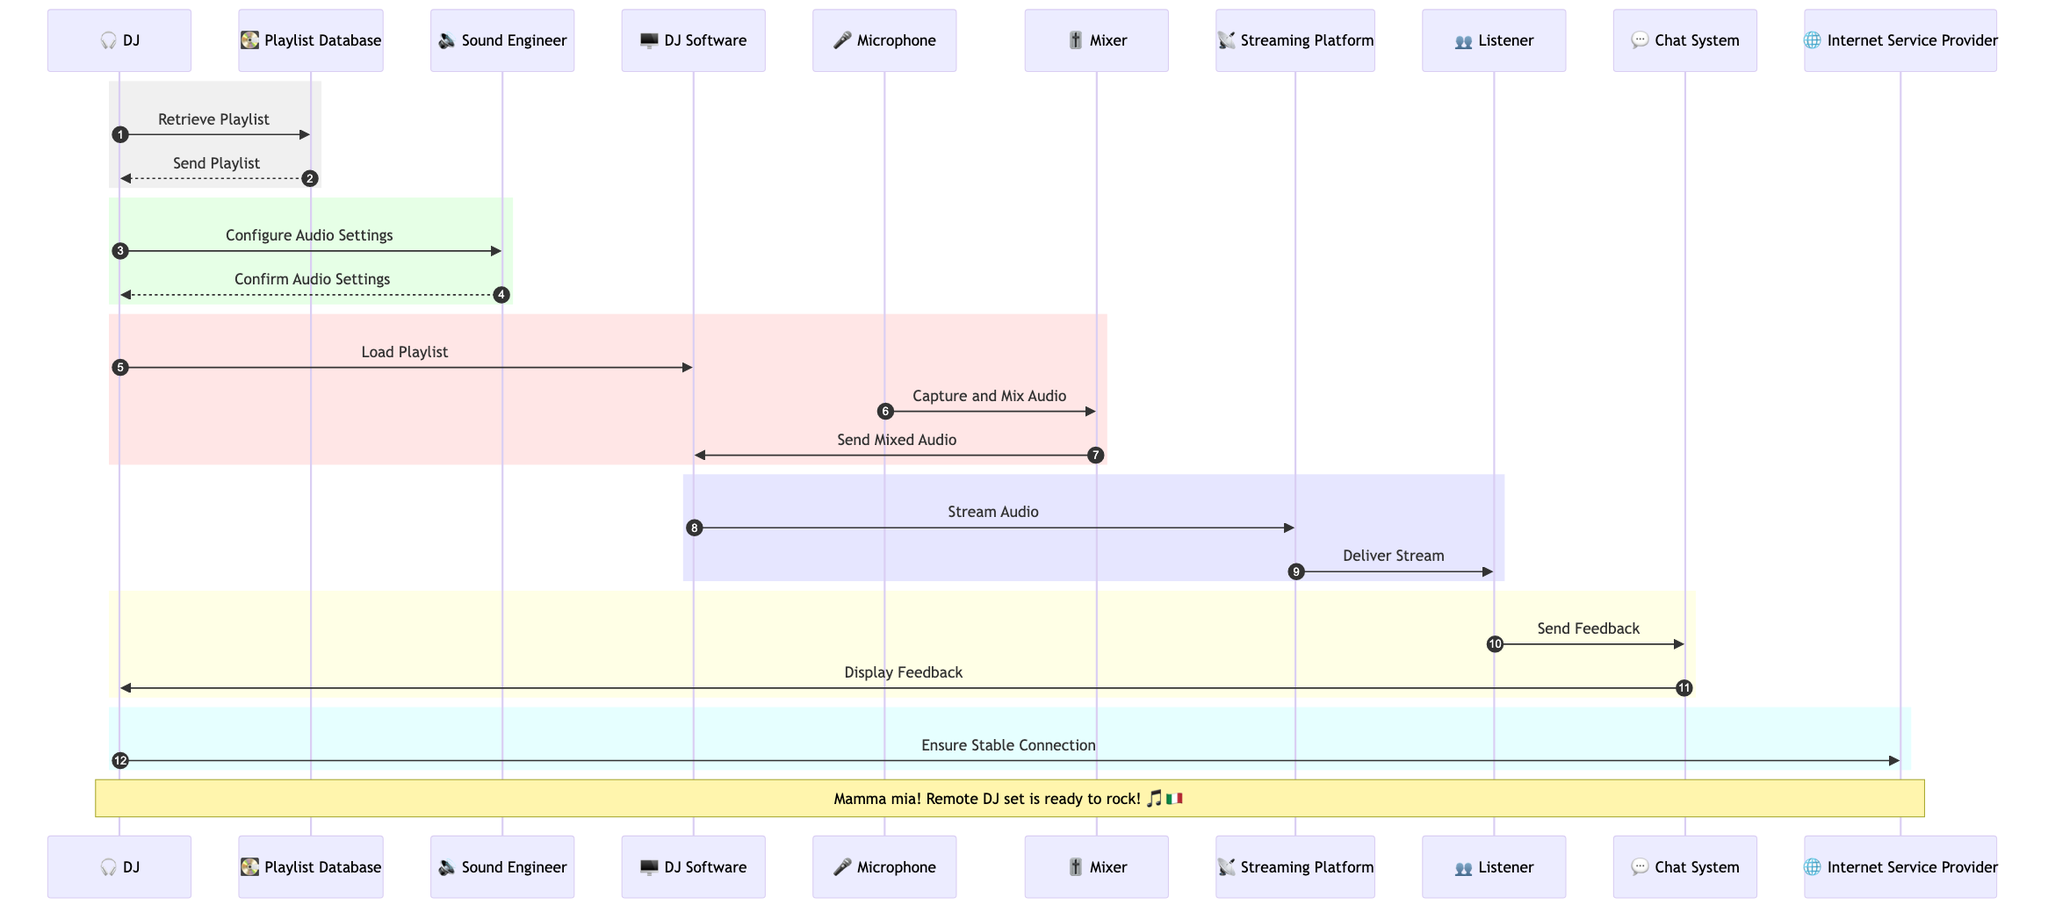What is the first action the DJ takes? The DJ retrieves the playlist from the Playlist Database, which is the first step in the sequence diagram. This is indicated by the arrow from DJ to Playlist Database labeled "Retrieve Playlist."
Answer: Retrieve Playlist How many main actors are involved in the broadcast? The sequence diagram lists 5 main actors: DJ, Listener, Streaming Platform, Sound Engineer, and Internet Service Provider. Counting these gives us a total of 5 actors.
Answer: 5 Which participant sends the stream to the listener? The Streaming Platform is responsible for delivering the stream to the Listener, as shown by the arrow from Streaming Platform to Listener labeled "Deliver Stream."
Answer: Streaming Platform What action does the Sound Engineer confirm? The Sound Engineer confirms the audio settings configured by the DJ, as indicated by the arrow from Sound Engineer to DJ labeled "Confirm Audio Settings."
Answer: Confirm Audio Settings What happens after the DJ loads the playlist? After the DJ loads the playlist, the microphone captures audio and sends it to the mixer, which then sends the mixed audio to the DJ Software. This flow begins with the DJ loading the playlist and continues with audio capture and mixing.
Answer: Capture and Mix Audio What does the listener do to give feedback? The Listener sends feedback through the Chat System, as represented by the arrow from Listener to Chat System labeled "Send Feedback."
Answer: Send Feedback What is the last action the DJ takes in the sequence? The last action taken by the DJ in the sequence is ensuring a stable internet connection with the Internet Service Provider, shown by the arrow from DJ to ISP labeled "Ensure Stable Connection."
Answer: Ensure Stable Connection Which system is responsible for mixing the audio? The Mixer is responsible for mixing the audio, as indicated by its role in the sequence where it captures audio from the microphone and sends it to the DJ Software.
Answer: Mixer What action does the DJ Software perform to start the streaming process? The DJ Software streams the audio to the Streaming Platform, which is shown by the arrow from DJ Software to Streaming Platform labeled "Stream Audio."
Answer: Stream Audio What does the DJ do after retrieving the playlist? After retrieving the playlist, the DJ configures the audio settings with the Sound Engineer, as indicated by the sequence flow following the action of retrieving the playlist.
Answer: Configure Audio Settings 